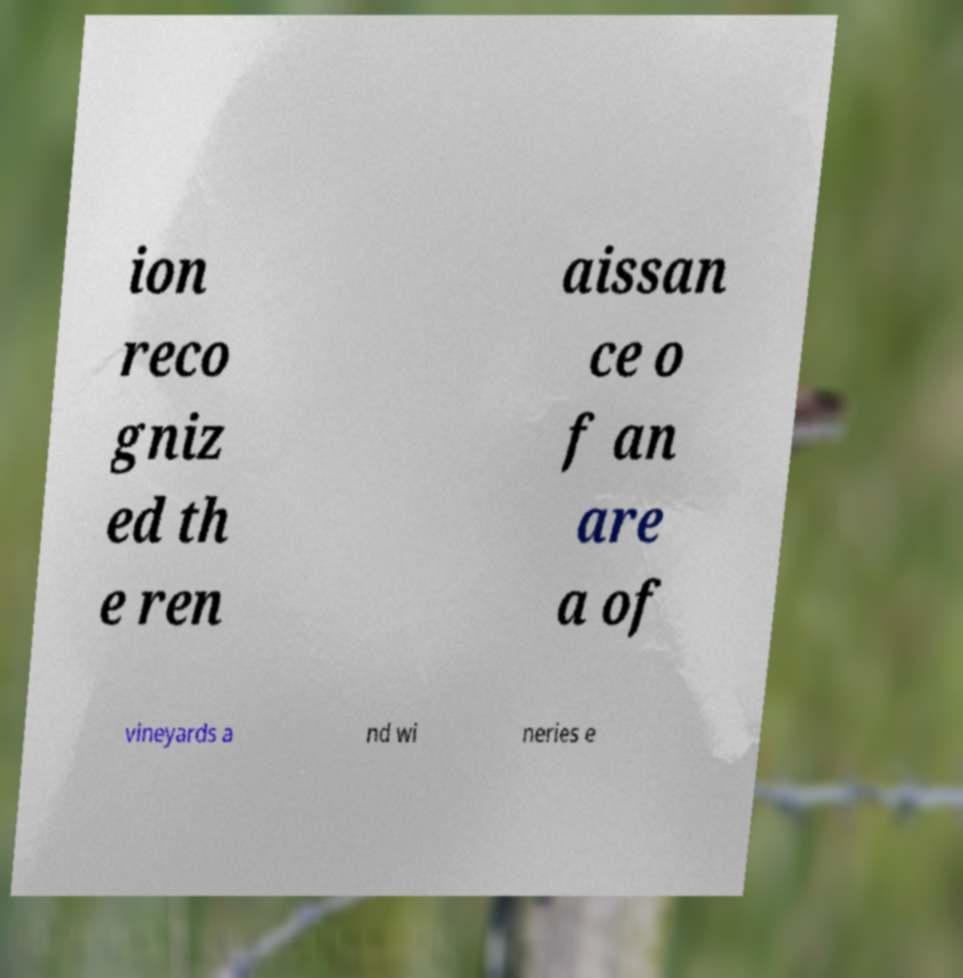Can you accurately transcribe the text from the provided image for me? ion reco gniz ed th e ren aissan ce o f an are a of vineyards a nd wi neries e 